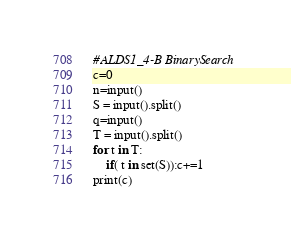Convert code to text. <code><loc_0><loc_0><loc_500><loc_500><_Python_>#ALDS1_4-B BinarySearch
c=0
n=input()
S = input().split()
q=input()
T = input().split()
for t in T:
    if( t in set(S)):c+=1
print(c)</code> 